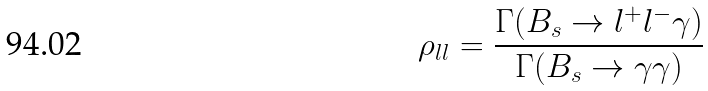Convert formula to latex. <formula><loc_0><loc_0><loc_500><loc_500>\rho _ { l l } = \frac { \Gamma ( B _ { s } \to l ^ { + } l ^ { - } \gamma ) } { \Gamma ( B _ { s } \to \gamma \gamma ) }</formula> 